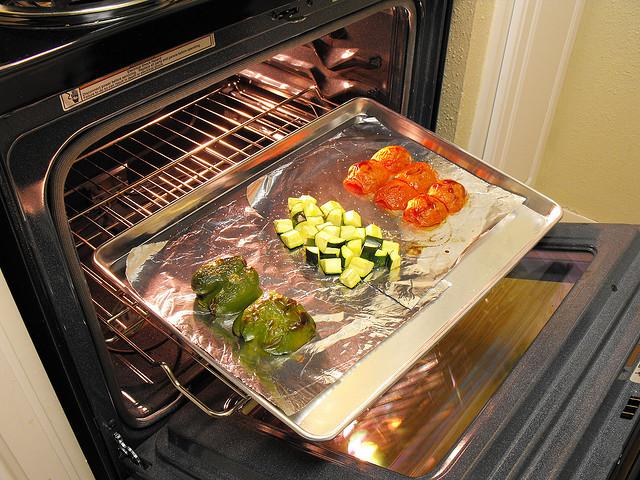How many tomato slices?
Write a very short answer. 6. Would a vegetarian eat this?
Be succinct. Yes. Did the food make a mess?
Answer briefly. No. What color  is the oven?
Write a very short answer. Black. How many different types of vegetables are there shown?
Concise answer only. 3. 